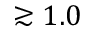<formula> <loc_0><loc_0><loc_500><loc_500>\gtrsim 1 . 0</formula> 